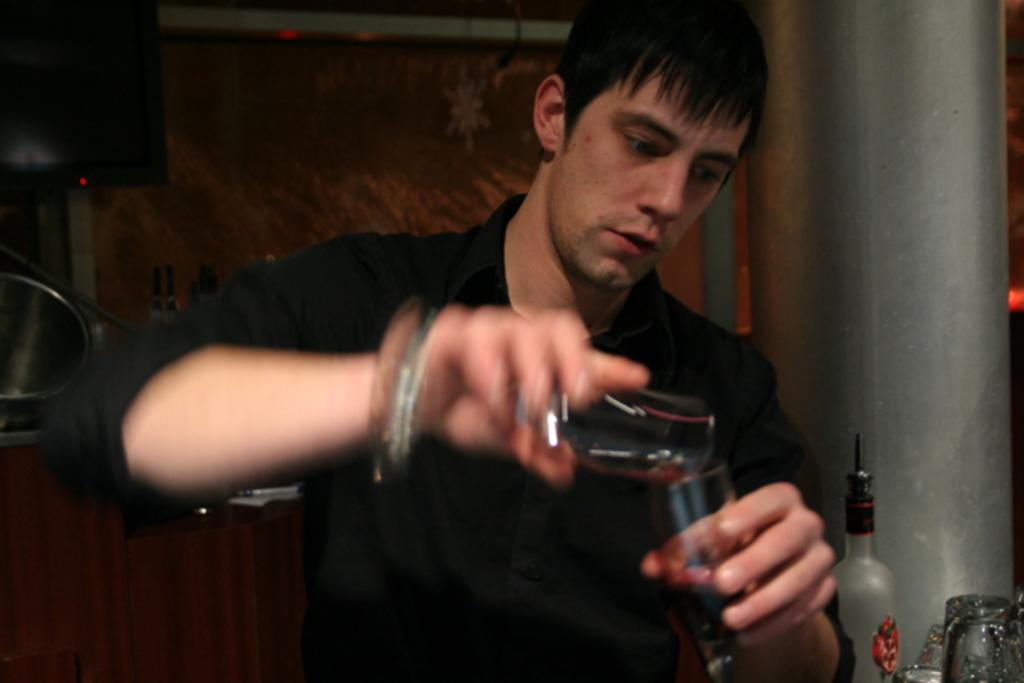What is the main subject of the image? The main subject of the image is a man. What is the man doing in the image? The man is standing and mixing wine with his hands. What is the man wearing in the image? The man is wearing a black color shirt. Can you see any squirrels in the image? There are no squirrels present in the image. Is the man in the image making a request to someone? The image does not provide any information about the man making a request to someone. 